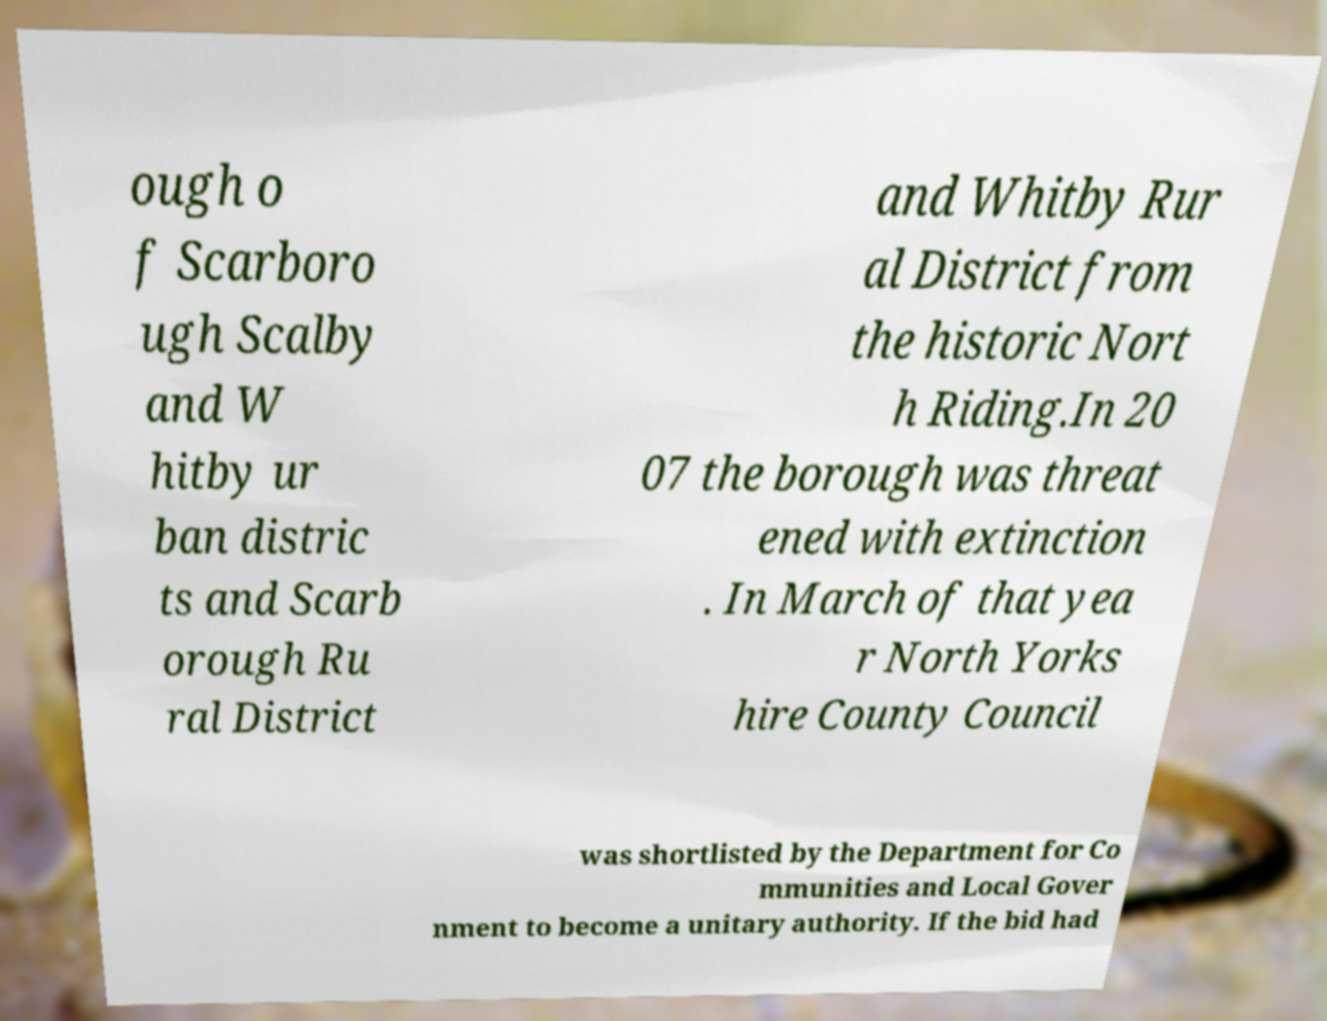There's text embedded in this image that I need extracted. Can you transcribe it verbatim? ough o f Scarboro ugh Scalby and W hitby ur ban distric ts and Scarb orough Ru ral District and Whitby Rur al District from the historic Nort h Riding.In 20 07 the borough was threat ened with extinction . In March of that yea r North Yorks hire County Council was shortlisted by the Department for Co mmunities and Local Gover nment to become a unitary authority. If the bid had 